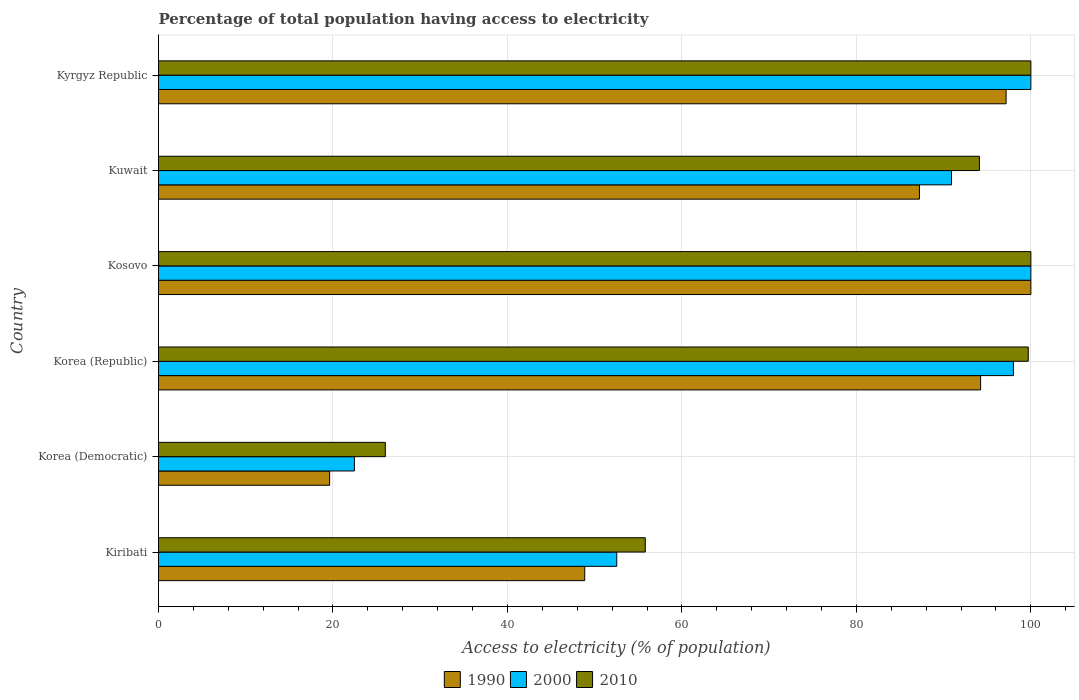How many different coloured bars are there?
Offer a terse response. 3. Are the number of bars per tick equal to the number of legend labels?
Your answer should be very brief. Yes. How many bars are there on the 2nd tick from the bottom?
Provide a succinct answer. 3. What is the label of the 3rd group of bars from the top?
Provide a succinct answer. Kosovo. In how many cases, is the number of bars for a given country not equal to the number of legend labels?
Give a very brief answer. 0. Across all countries, what is the maximum percentage of population that have access to electricity in 1990?
Provide a succinct answer. 100. Across all countries, what is the minimum percentage of population that have access to electricity in 2000?
Provide a short and direct response. 22.46. In which country was the percentage of population that have access to electricity in 2010 maximum?
Keep it short and to the point. Kosovo. In which country was the percentage of population that have access to electricity in 2000 minimum?
Your answer should be compact. Korea (Democratic). What is the total percentage of population that have access to electricity in 1990 in the graph?
Your response must be concise. 447.1. What is the difference between the percentage of population that have access to electricity in 1990 in Kiribati and that in Kosovo?
Offer a terse response. -51.14. What is the difference between the percentage of population that have access to electricity in 2010 in Korea (Democratic) and the percentage of population that have access to electricity in 1990 in Kuwait?
Keep it short and to the point. -61.23. What is the average percentage of population that have access to electricity in 1990 per country?
Offer a terse response. 74.52. What is the difference between the percentage of population that have access to electricity in 1990 and percentage of population that have access to electricity in 2000 in Korea (Republic)?
Provide a succinct answer. -3.76. What is the ratio of the percentage of population that have access to electricity in 2010 in Korea (Republic) to that in Kosovo?
Make the answer very short. 1. Is the difference between the percentage of population that have access to electricity in 1990 in Kosovo and Kyrgyz Republic greater than the difference between the percentage of population that have access to electricity in 2000 in Kosovo and Kyrgyz Republic?
Your answer should be compact. Yes. What is the difference between the highest and the second highest percentage of population that have access to electricity in 2010?
Your answer should be compact. 0. In how many countries, is the percentage of population that have access to electricity in 2010 greater than the average percentage of population that have access to electricity in 2010 taken over all countries?
Your answer should be very brief. 4. Is the sum of the percentage of population that have access to electricity in 2000 in Kiribati and Korea (Democratic) greater than the maximum percentage of population that have access to electricity in 2010 across all countries?
Give a very brief answer. No. What is the difference between two consecutive major ticks on the X-axis?
Your answer should be compact. 20. What is the title of the graph?
Ensure brevity in your answer.  Percentage of total population having access to electricity. What is the label or title of the X-axis?
Keep it short and to the point. Access to electricity (% of population). What is the label or title of the Y-axis?
Your response must be concise. Country. What is the Access to electricity (% of population) in 1990 in Kiribati?
Your response must be concise. 48.86. What is the Access to electricity (% of population) of 2000 in Kiribati?
Ensure brevity in your answer.  52.53. What is the Access to electricity (% of population) in 2010 in Kiribati?
Keep it short and to the point. 55.8. What is the Access to electricity (% of population) of 1990 in Korea (Democratic)?
Your answer should be very brief. 19.62. What is the Access to electricity (% of population) of 2000 in Korea (Democratic)?
Your answer should be very brief. 22.46. What is the Access to electricity (% of population) of 1990 in Korea (Republic)?
Keep it short and to the point. 94.24. What is the Access to electricity (% of population) of 2000 in Korea (Republic)?
Give a very brief answer. 98. What is the Access to electricity (% of population) of 2010 in Korea (Republic)?
Make the answer very short. 99.7. What is the Access to electricity (% of population) of 1990 in Kosovo?
Offer a terse response. 100. What is the Access to electricity (% of population) in 2010 in Kosovo?
Provide a succinct answer. 100. What is the Access to electricity (% of population) of 1990 in Kuwait?
Make the answer very short. 87.23. What is the Access to electricity (% of population) of 2000 in Kuwait?
Keep it short and to the point. 90.9. What is the Access to electricity (% of population) in 2010 in Kuwait?
Your response must be concise. 94.1. What is the Access to electricity (% of population) in 1990 in Kyrgyz Republic?
Your answer should be very brief. 97.16. What is the Access to electricity (% of population) in 2000 in Kyrgyz Republic?
Your answer should be very brief. 100. Across all countries, what is the maximum Access to electricity (% of population) of 1990?
Keep it short and to the point. 100. Across all countries, what is the minimum Access to electricity (% of population) of 1990?
Ensure brevity in your answer.  19.62. Across all countries, what is the minimum Access to electricity (% of population) of 2000?
Keep it short and to the point. 22.46. Across all countries, what is the minimum Access to electricity (% of population) in 2010?
Offer a terse response. 26. What is the total Access to electricity (% of population) of 1990 in the graph?
Ensure brevity in your answer.  447.1. What is the total Access to electricity (% of population) of 2000 in the graph?
Your answer should be very brief. 463.89. What is the total Access to electricity (% of population) of 2010 in the graph?
Your answer should be compact. 475.6. What is the difference between the Access to electricity (% of population) of 1990 in Kiribati and that in Korea (Democratic)?
Offer a very short reply. 29.24. What is the difference between the Access to electricity (% of population) of 2000 in Kiribati and that in Korea (Democratic)?
Make the answer very short. 30.07. What is the difference between the Access to electricity (% of population) in 2010 in Kiribati and that in Korea (Democratic)?
Your answer should be compact. 29.8. What is the difference between the Access to electricity (% of population) of 1990 in Kiribati and that in Korea (Republic)?
Ensure brevity in your answer.  -45.38. What is the difference between the Access to electricity (% of population) in 2000 in Kiribati and that in Korea (Republic)?
Your answer should be very brief. -45.47. What is the difference between the Access to electricity (% of population) in 2010 in Kiribati and that in Korea (Republic)?
Provide a succinct answer. -43.9. What is the difference between the Access to electricity (% of population) of 1990 in Kiribati and that in Kosovo?
Offer a very short reply. -51.14. What is the difference between the Access to electricity (% of population) of 2000 in Kiribati and that in Kosovo?
Provide a short and direct response. -47.47. What is the difference between the Access to electricity (% of population) in 2010 in Kiribati and that in Kosovo?
Keep it short and to the point. -44.2. What is the difference between the Access to electricity (% of population) of 1990 in Kiribati and that in Kuwait?
Offer a terse response. -38.37. What is the difference between the Access to electricity (% of population) of 2000 in Kiribati and that in Kuwait?
Provide a short and direct response. -38.37. What is the difference between the Access to electricity (% of population) of 2010 in Kiribati and that in Kuwait?
Make the answer very short. -38.3. What is the difference between the Access to electricity (% of population) of 1990 in Kiribati and that in Kyrgyz Republic?
Your answer should be compact. -48.3. What is the difference between the Access to electricity (% of population) of 2000 in Kiribati and that in Kyrgyz Republic?
Keep it short and to the point. -47.47. What is the difference between the Access to electricity (% of population) of 2010 in Kiribati and that in Kyrgyz Republic?
Ensure brevity in your answer.  -44.2. What is the difference between the Access to electricity (% of population) in 1990 in Korea (Democratic) and that in Korea (Republic)?
Provide a succinct answer. -74.62. What is the difference between the Access to electricity (% of population) of 2000 in Korea (Democratic) and that in Korea (Republic)?
Your answer should be very brief. -75.54. What is the difference between the Access to electricity (% of population) in 2010 in Korea (Democratic) and that in Korea (Republic)?
Your answer should be very brief. -73.7. What is the difference between the Access to electricity (% of population) of 1990 in Korea (Democratic) and that in Kosovo?
Make the answer very short. -80.38. What is the difference between the Access to electricity (% of population) in 2000 in Korea (Democratic) and that in Kosovo?
Provide a succinct answer. -77.54. What is the difference between the Access to electricity (% of population) of 2010 in Korea (Democratic) and that in Kosovo?
Your answer should be very brief. -74. What is the difference between the Access to electricity (% of population) of 1990 in Korea (Democratic) and that in Kuwait?
Provide a short and direct response. -67.61. What is the difference between the Access to electricity (% of population) of 2000 in Korea (Democratic) and that in Kuwait?
Your answer should be very brief. -68.44. What is the difference between the Access to electricity (% of population) in 2010 in Korea (Democratic) and that in Kuwait?
Make the answer very short. -68.1. What is the difference between the Access to electricity (% of population) in 1990 in Korea (Democratic) and that in Kyrgyz Republic?
Make the answer very short. -77.54. What is the difference between the Access to electricity (% of population) of 2000 in Korea (Democratic) and that in Kyrgyz Republic?
Keep it short and to the point. -77.54. What is the difference between the Access to electricity (% of population) in 2010 in Korea (Democratic) and that in Kyrgyz Republic?
Your response must be concise. -74. What is the difference between the Access to electricity (% of population) in 1990 in Korea (Republic) and that in Kosovo?
Keep it short and to the point. -5.76. What is the difference between the Access to electricity (% of population) of 1990 in Korea (Republic) and that in Kuwait?
Offer a very short reply. 7.01. What is the difference between the Access to electricity (% of population) in 2000 in Korea (Republic) and that in Kuwait?
Give a very brief answer. 7.1. What is the difference between the Access to electricity (% of population) of 1990 in Korea (Republic) and that in Kyrgyz Republic?
Your answer should be compact. -2.92. What is the difference between the Access to electricity (% of population) of 2000 in Korea (Republic) and that in Kyrgyz Republic?
Offer a terse response. -2. What is the difference between the Access to electricity (% of population) in 1990 in Kosovo and that in Kuwait?
Your response must be concise. 12.77. What is the difference between the Access to electricity (% of population) in 2000 in Kosovo and that in Kuwait?
Offer a very short reply. 9.1. What is the difference between the Access to electricity (% of population) in 1990 in Kosovo and that in Kyrgyz Republic?
Offer a terse response. 2.84. What is the difference between the Access to electricity (% of population) in 1990 in Kuwait and that in Kyrgyz Republic?
Keep it short and to the point. -9.93. What is the difference between the Access to electricity (% of population) of 2000 in Kuwait and that in Kyrgyz Republic?
Offer a terse response. -9.1. What is the difference between the Access to electricity (% of population) of 1990 in Kiribati and the Access to electricity (% of population) of 2000 in Korea (Democratic)?
Provide a short and direct response. 26.4. What is the difference between the Access to electricity (% of population) of 1990 in Kiribati and the Access to electricity (% of population) of 2010 in Korea (Democratic)?
Offer a very short reply. 22.86. What is the difference between the Access to electricity (% of population) of 2000 in Kiribati and the Access to electricity (% of population) of 2010 in Korea (Democratic)?
Make the answer very short. 26.53. What is the difference between the Access to electricity (% of population) in 1990 in Kiribati and the Access to electricity (% of population) in 2000 in Korea (Republic)?
Provide a succinct answer. -49.14. What is the difference between the Access to electricity (% of population) in 1990 in Kiribati and the Access to electricity (% of population) in 2010 in Korea (Republic)?
Make the answer very short. -50.84. What is the difference between the Access to electricity (% of population) in 2000 in Kiribati and the Access to electricity (% of population) in 2010 in Korea (Republic)?
Offer a very short reply. -47.17. What is the difference between the Access to electricity (% of population) in 1990 in Kiribati and the Access to electricity (% of population) in 2000 in Kosovo?
Make the answer very short. -51.14. What is the difference between the Access to electricity (% of population) of 1990 in Kiribati and the Access to electricity (% of population) of 2010 in Kosovo?
Your answer should be very brief. -51.14. What is the difference between the Access to electricity (% of population) of 2000 in Kiribati and the Access to electricity (% of population) of 2010 in Kosovo?
Keep it short and to the point. -47.47. What is the difference between the Access to electricity (% of population) of 1990 in Kiribati and the Access to electricity (% of population) of 2000 in Kuwait?
Offer a very short reply. -42.04. What is the difference between the Access to electricity (% of population) in 1990 in Kiribati and the Access to electricity (% of population) in 2010 in Kuwait?
Provide a succinct answer. -45.24. What is the difference between the Access to electricity (% of population) of 2000 in Kiribati and the Access to electricity (% of population) of 2010 in Kuwait?
Your answer should be very brief. -41.57. What is the difference between the Access to electricity (% of population) in 1990 in Kiribati and the Access to electricity (% of population) in 2000 in Kyrgyz Republic?
Make the answer very short. -51.14. What is the difference between the Access to electricity (% of population) in 1990 in Kiribati and the Access to electricity (% of population) in 2010 in Kyrgyz Republic?
Make the answer very short. -51.14. What is the difference between the Access to electricity (% of population) of 2000 in Kiribati and the Access to electricity (% of population) of 2010 in Kyrgyz Republic?
Keep it short and to the point. -47.47. What is the difference between the Access to electricity (% of population) in 1990 in Korea (Democratic) and the Access to electricity (% of population) in 2000 in Korea (Republic)?
Offer a terse response. -78.38. What is the difference between the Access to electricity (% of population) of 1990 in Korea (Democratic) and the Access to electricity (% of population) of 2010 in Korea (Republic)?
Your answer should be very brief. -80.08. What is the difference between the Access to electricity (% of population) in 2000 in Korea (Democratic) and the Access to electricity (% of population) in 2010 in Korea (Republic)?
Your response must be concise. -77.24. What is the difference between the Access to electricity (% of population) of 1990 in Korea (Democratic) and the Access to electricity (% of population) of 2000 in Kosovo?
Your response must be concise. -80.38. What is the difference between the Access to electricity (% of population) of 1990 in Korea (Democratic) and the Access to electricity (% of population) of 2010 in Kosovo?
Ensure brevity in your answer.  -80.38. What is the difference between the Access to electricity (% of population) of 2000 in Korea (Democratic) and the Access to electricity (% of population) of 2010 in Kosovo?
Give a very brief answer. -77.54. What is the difference between the Access to electricity (% of population) in 1990 in Korea (Democratic) and the Access to electricity (% of population) in 2000 in Kuwait?
Offer a terse response. -71.28. What is the difference between the Access to electricity (% of population) in 1990 in Korea (Democratic) and the Access to electricity (% of population) in 2010 in Kuwait?
Ensure brevity in your answer.  -74.48. What is the difference between the Access to electricity (% of population) of 2000 in Korea (Democratic) and the Access to electricity (% of population) of 2010 in Kuwait?
Your answer should be very brief. -71.64. What is the difference between the Access to electricity (% of population) of 1990 in Korea (Democratic) and the Access to electricity (% of population) of 2000 in Kyrgyz Republic?
Provide a short and direct response. -80.38. What is the difference between the Access to electricity (% of population) of 1990 in Korea (Democratic) and the Access to electricity (% of population) of 2010 in Kyrgyz Republic?
Give a very brief answer. -80.38. What is the difference between the Access to electricity (% of population) in 2000 in Korea (Democratic) and the Access to electricity (% of population) in 2010 in Kyrgyz Republic?
Provide a succinct answer. -77.54. What is the difference between the Access to electricity (% of population) of 1990 in Korea (Republic) and the Access to electricity (% of population) of 2000 in Kosovo?
Make the answer very short. -5.76. What is the difference between the Access to electricity (% of population) in 1990 in Korea (Republic) and the Access to electricity (% of population) in 2010 in Kosovo?
Ensure brevity in your answer.  -5.76. What is the difference between the Access to electricity (% of population) of 1990 in Korea (Republic) and the Access to electricity (% of population) of 2000 in Kuwait?
Give a very brief answer. 3.34. What is the difference between the Access to electricity (% of population) in 1990 in Korea (Republic) and the Access to electricity (% of population) in 2010 in Kuwait?
Offer a very short reply. 0.14. What is the difference between the Access to electricity (% of population) in 1990 in Korea (Republic) and the Access to electricity (% of population) in 2000 in Kyrgyz Republic?
Your response must be concise. -5.76. What is the difference between the Access to electricity (% of population) in 1990 in Korea (Republic) and the Access to electricity (% of population) in 2010 in Kyrgyz Republic?
Keep it short and to the point. -5.76. What is the difference between the Access to electricity (% of population) in 2000 in Korea (Republic) and the Access to electricity (% of population) in 2010 in Kyrgyz Republic?
Ensure brevity in your answer.  -2. What is the difference between the Access to electricity (% of population) in 1990 in Kosovo and the Access to electricity (% of population) in 2000 in Kuwait?
Give a very brief answer. 9.1. What is the difference between the Access to electricity (% of population) of 1990 in Kosovo and the Access to electricity (% of population) of 2010 in Kuwait?
Your response must be concise. 5.9. What is the difference between the Access to electricity (% of population) in 1990 in Kosovo and the Access to electricity (% of population) in 2000 in Kyrgyz Republic?
Keep it short and to the point. 0. What is the difference between the Access to electricity (% of population) in 1990 in Kosovo and the Access to electricity (% of population) in 2010 in Kyrgyz Republic?
Provide a short and direct response. 0. What is the difference between the Access to electricity (% of population) in 1990 in Kuwait and the Access to electricity (% of population) in 2000 in Kyrgyz Republic?
Ensure brevity in your answer.  -12.77. What is the difference between the Access to electricity (% of population) in 1990 in Kuwait and the Access to electricity (% of population) in 2010 in Kyrgyz Republic?
Your response must be concise. -12.77. What is the difference between the Access to electricity (% of population) in 2000 in Kuwait and the Access to electricity (% of population) in 2010 in Kyrgyz Republic?
Your answer should be compact. -9.1. What is the average Access to electricity (% of population) in 1990 per country?
Give a very brief answer. 74.52. What is the average Access to electricity (% of population) in 2000 per country?
Offer a terse response. 77.31. What is the average Access to electricity (% of population) of 2010 per country?
Offer a very short reply. 79.27. What is the difference between the Access to electricity (% of population) of 1990 and Access to electricity (% of population) of 2000 in Kiribati?
Make the answer very short. -3.67. What is the difference between the Access to electricity (% of population) in 1990 and Access to electricity (% of population) in 2010 in Kiribati?
Your answer should be compact. -6.94. What is the difference between the Access to electricity (% of population) of 2000 and Access to electricity (% of population) of 2010 in Kiribati?
Provide a short and direct response. -3.27. What is the difference between the Access to electricity (% of population) of 1990 and Access to electricity (% of population) of 2000 in Korea (Democratic)?
Offer a very short reply. -2.84. What is the difference between the Access to electricity (% of population) of 1990 and Access to electricity (% of population) of 2010 in Korea (Democratic)?
Keep it short and to the point. -6.38. What is the difference between the Access to electricity (% of population) in 2000 and Access to electricity (% of population) in 2010 in Korea (Democratic)?
Offer a very short reply. -3.54. What is the difference between the Access to electricity (% of population) of 1990 and Access to electricity (% of population) of 2000 in Korea (Republic)?
Offer a terse response. -3.76. What is the difference between the Access to electricity (% of population) of 1990 and Access to electricity (% of population) of 2010 in Korea (Republic)?
Give a very brief answer. -5.46. What is the difference between the Access to electricity (% of population) of 2000 and Access to electricity (% of population) of 2010 in Korea (Republic)?
Give a very brief answer. -1.7. What is the difference between the Access to electricity (% of population) in 1990 and Access to electricity (% of population) in 2000 in Kosovo?
Give a very brief answer. 0. What is the difference between the Access to electricity (% of population) in 1990 and Access to electricity (% of population) in 2010 in Kosovo?
Give a very brief answer. 0. What is the difference between the Access to electricity (% of population) of 1990 and Access to electricity (% of population) of 2000 in Kuwait?
Your answer should be very brief. -3.67. What is the difference between the Access to electricity (% of population) in 1990 and Access to electricity (% of population) in 2010 in Kuwait?
Keep it short and to the point. -6.87. What is the difference between the Access to electricity (% of population) in 2000 and Access to electricity (% of population) in 2010 in Kuwait?
Make the answer very short. -3.2. What is the difference between the Access to electricity (% of population) in 1990 and Access to electricity (% of population) in 2000 in Kyrgyz Republic?
Your response must be concise. -2.84. What is the difference between the Access to electricity (% of population) of 1990 and Access to electricity (% of population) of 2010 in Kyrgyz Republic?
Offer a terse response. -2.84. What is the difference between the Access to electricity (% of population) of 2000 and Access to electricity (% of population) of 2010 in Kyrgyz Republic?
Make the answer very short. 0. What is the ratio of the Access to electricity (% of population) in 1990 in Kiribati to that in Korea (Democratic)?
Offer a terse response. 2.49. What is the ratio of the Access to electricity (% of population) in 2000 in Kiribati to that in Korea (Democratic)?
Provide a succinct answer. 2.34. What is the ratio of the Access to electricity (% of population) in 2010 in Kiribati to that in Korea (Democratic)?
Your response must be concise. 2.15. What is the ratio of the Access to electricity (% of population) in 1990 in Kiribati to that in Korea (Republic)?
Keep it short and to the point. 0.52. What is the ratio of the Access to electricity (% of population) in 2000 in Kiribati to that in Korea (Republic)?
Your answer should be compact. 0.54. What is the ratio of the Access to electricity (% of population) of 2010 in Kiribati to that in Korea (Republic)?
Your answer should be compact. 0.56. What is the ratio of the Access to electricity (% of population) in 1990 in Kiribati to that in Kosovo?
Ensure brevity in your answer.  0.49. What is the ratio of the Access to electricity (% of population) in 2000 in Kiribati to that in Kosovo?
Your answer should be very brief. 0.53. What is the ratio of the Access to electricity (% of population) of 2010 in Kiribati to that in Kosovo?
Your answer should be very brief. 0.56. What is the ratio of the Access to electricity (% of population) of 1990 in Kiribati to that in Kuwait?
Your answer should be very brief. 0.56. What is the ratio of the Access to electricity (% of population) in 2000 in Kiribati to that in Kuwait?
Your response must be concise. 0.58. What is the ratio of the Access to electricity (% of population) of 2010 in Kiribati to that in Kuwait?
Your answer should be compact. 0.59. What is the ratio of the Access to electricity (% of population) in 1990 in Kiribati to that in Kyrgyz Republic?
Make the answer very short. 0.5. What is the ratio of the Access to electricity (% of population) in 2000 in Kiribati to that in Kyrgyz Republic?
Ensure brevity in your answer.  0.53. What is the ratio of the Access to electricity (% of population) of 2010 in Kiribati to that in Kyrgyz Republic?
Your answer should be compact. 0.56. What is the ratio of the Access to electricity (% of population) of 1990 in Korea (Democratic) to that in Korea (Republic)?
Give a very brief answer. 0.21. What is the ratio of the Access to electricity (% of population) in 2000 in Korea (Democratic) to that in Korea (Republic)?
Your response must be concise. 0.23. What is the ratio of the Access to electricity (% of population) of 2010 in Korea (Democratic) to that in Korea (Republic)?
Your answer should be compact. 0.26. What is the ratio of the Access to electricity (% of population) in 1990 in Korea (Democratic) to that in Kosovo?
Provide a succinct answer. 0.2. What is the ratio of the Access to electricity (% of population) of 2000 in Korea (Democratic) to that in Kosovo?
Ensure brevity in your answer.  0.22. What is the ratio of the Access to electricity (% of population) in 2010 in Korea (Democratic) to that in Kosovo?
Give a very brief answer. 0.26. What is the ratio of the Access to electricity (% of population) of 1990 in Korea (Democratic) to that in Kuwait?
Give a very brief answer. 0.22. What is the ratio of the Access to electricity (% of population) in 2000 in Korea (Democratic) to that in Kuwait?
Offer a terse response. 0.25. What is the ratio of the Access to electricity (% of population) in 2010 in Korea (Democratic) to that in Kuwait?
Offer a terse response. 0.28. What is the ratio of the Access to electricity (% of population) in 1990 in Korea (Democratic) to that in Kyrgyz Republic?
Your answer should be compact. 0.2. What is the ratio of the Access to electricity (% of population) of 2000 in Korea (Democratic) to that in Kyrgyz Republic?
Your response must be concise. 0.22. What is the ratio of the Access to electricity (% of population) in 2010 in Korea (Democratic) to that in Kyrgyz Republic?
Your answer should be very brief. 0.26. What is the ratio of the Access to electricity (% of population) of 1990 in Korea (Republic) to that in Kosovo?
Provide a succinct answer. 0.94. What is the ratio of the Access to electricity (% of population) of 2000 in Korea (Republic) to that in Kosovo?
Keep it short and to the point. 0.98. What is the ratio of the Access to electricity (% of population) in 1990 in Korea (Republic) to that in Kuwait?
Offer a very short reply. 1.08. What is the ratio of the Access to electricity (% of population) of 2000 in Korea (Republic) to that in Kuwait?
Your answer should be very brief. 1.08. What is the ratio of the Access to electricity (% of population) in 2010 in Korea (Republic) to that in Kuwait?
Your answer should be very brief. 1.06. What is the ratio of the Access to electricity (% of population) in 1990 in Korea (Republic) to that in Kyrgyz Republic?
Keep it short and to the point. 0.97. What is the ratio of the Access to electricity (% of population) of 1990 in Kosovo to that in Kuwait?
Keep it short and to the point. 1.15. What is the ratio of the Access to electricity (% of population) of 2000 in Kosovo to that in Kuwait?
Keep it short and to the point. 1.1. What is the ratio of the Access to electricity (% of population) of 2010 in Kosovo to that in Kuwait?
Your answer should be very brief. 1.06. What is the ratio of the Access to electricity (% of population) of 1990 in Kosovo to that in Kyrgyz Republic?
Offer a very short reply. 1.03. What is the ratio of the Access to electricity (% of population) in 2010 in Kosovo to that in Kyrgyz Republic?
Make the answer very short. 1. What is the ratio of the Access to electricity (% of population) in 1990 in Kuwait to that in Kyrgyz Republic?
Offer a terse response. 0.9. What is the ratio of the Access to electricity (% of population) in 2000 in Kuwait to that in Kyrgyz Republic?
Give a very brief answer. 0.91. What is the ratio of the Access to electricity (% of population) in 2010 in Kuwait to that in Kyrgyz Republic?
Keep it short and to the point. 0.94. What is the difference between the highest and the second highest Access to electricity (% of population) of 1990?
Offer a very short reply. 2.84. What is the difference between the highest and the lowest Access to electricity (% of population) in 1990?
Make the answer very short. 80.38. What is the difference between the highest and the lowest Access to electricity (% of population) in 2000?
Provide a succinct answer. 77.54. 